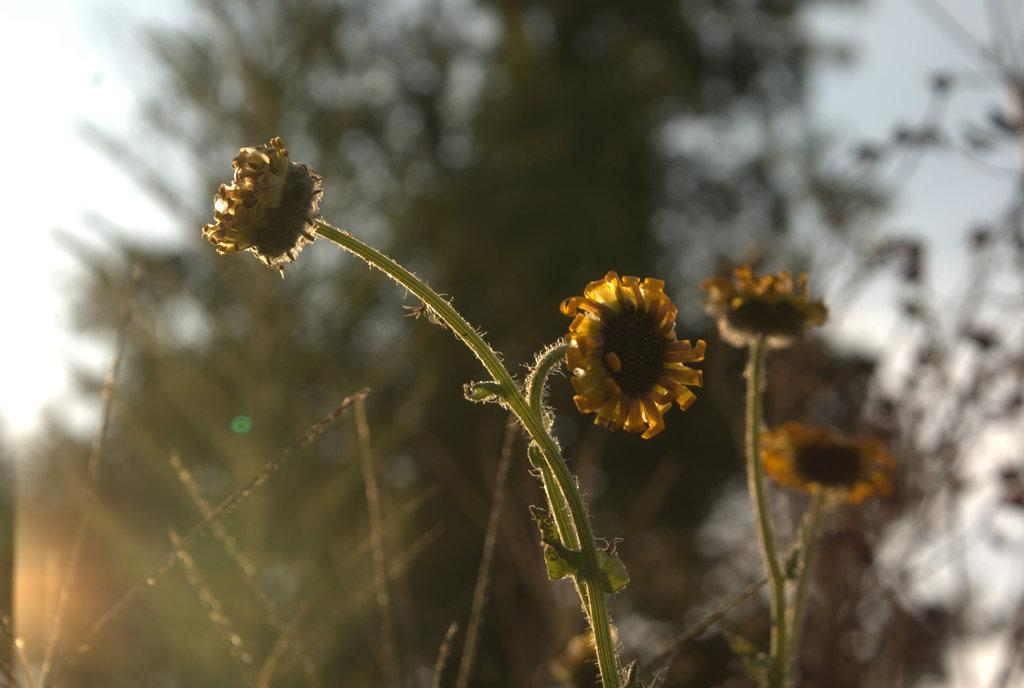What type of flora can be seen in the image? There are flowers, plants, and trees in the image. Can you describe the different types of vegetation present? The image contains flowers, plants, and trees. What is the common characteristic among these elements? They are all types of plants. What type of pain is the secretary experiencing in the image? There is no secretary or any indication of pain in the image; it features flowers, plants, and trees. 